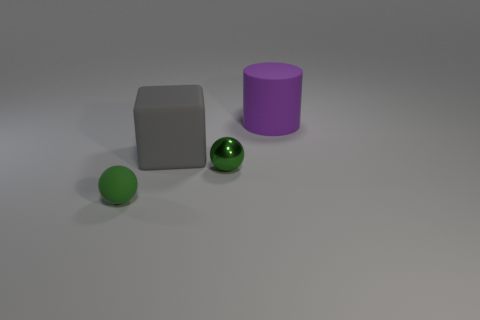Is the color of the small thing right of the green matte object the same as the tiny object that is left of the big cube?
Offer a very short reply. Yes. Are any yellow metallic objects visible?
Your response must be concise. No. How many objects are either tiny objects or green spheres on the right side of the small green matte sphere?
Offer a very short reply. 2. There is a green sphere to the left of the gray cube; does it have the same size as the purple matte cylinder?
Make the answer very short. No. How many other objects are the same size as the purple cylinder?
Keep it short and to the point. 1. What is the color of the large rubber cube?
Provide a succinct answer. Gray. What is the ball that is to the right of the small matte object made of?
Your answer should be compact. Metal. Are there the same number of large matte blocks that are to the right of the tiny green matte object and small rubber cylinders?
Offer a very short reply. No. Is the tiny green matte object the same shape as the tiny green metal object?
Provide a short and direct response. Yes. Are there any other things of the same color as the small shiny ball?
Keep it short and to the point. Yes. 